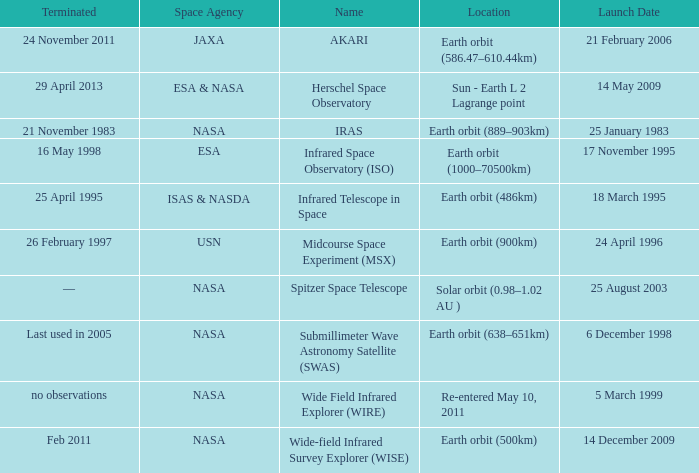Which space agency launched the herschel space observatory? ESA & NASA. 